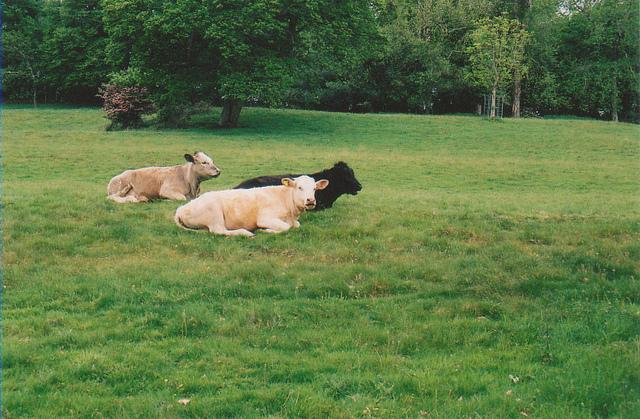What are the cows doing? Please explain your reasoning. laying down. The cows are laying down in the field of grass. 